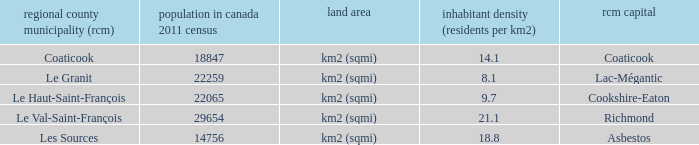What is the RCM that has a density of 9.7? Le Haut-Saint-François. 